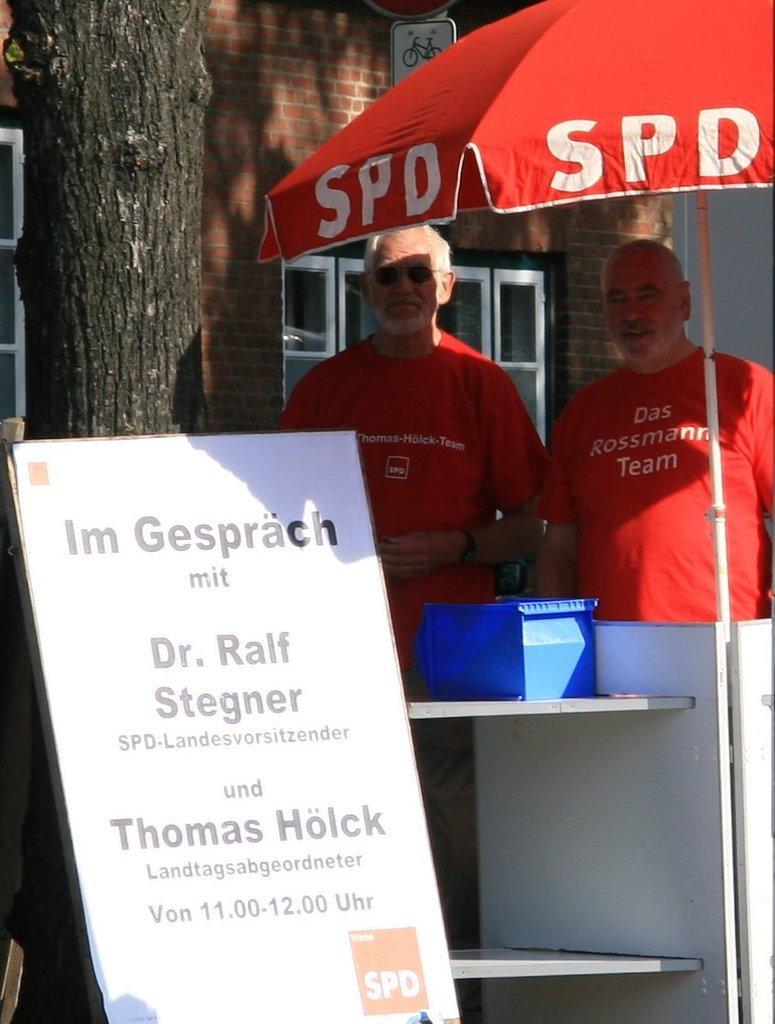Please provide a concise description of this image. In this image we can see a hoarding placed on a tree. To the right side of the image we can see two persons standing wearing red t shirts. In the background we can see umbrella and a building. 